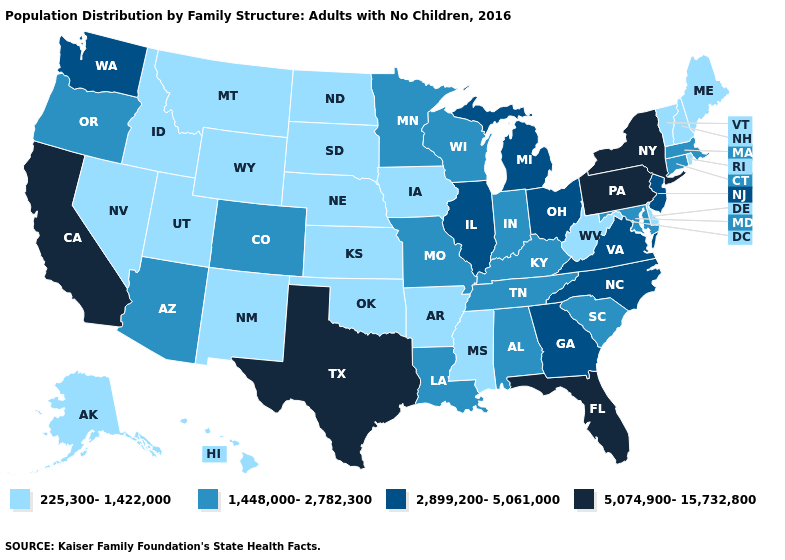Does the first symbol in the legend represent the smallest category?
Answer briefly. Yes. What is the value of Delaware?
Give a very brief answer. 225,300-1,422,000. Which states hav the highest value in the MidWest?
Keep it brief. Illinois, Michigan, Ohio. What is the lowest value in the South?
Quick response, please. 225,300-1,422,000. What is the value of Tennessee?
Keep it brief. 1,448,000-2,782,300. Does New Hampshire have the lowest value in the Northeast?
Write a very short answer. Yes. Does New Jersey have a higher value than Pennsylvania?
Be succinct. No. Which states have the lowest value in the MidWest?
Keep it brief. Iowa, Kansas, Nebraska, North Dakota, South Dakota. Which states have the highest value in the USA?
Write a very short answer. California, Florida, New York, Pennsylvania, Texas. What is the value of Ohio?
Quick response, please. 2,899,200-5,061,000. What is the value of North Dakota?
Write a very short answer. 225,300-1,422,000. What is the value of Rhode Island?
Keep it brief. 225,300-1,422,000. Name the states that have a value in the range 2,899,200-5,061,000?
Give a very brief answer. Georgia, Illinois, Michigan, New Jersey, North Carolina, Ohio, Virginia, Washington. Which states hav the highest value in the Northeast?
Give a very brief answer. New York, Pennsylvania. Among the states that border Massachusetts , does New York have the highest value?
Concise answer only. Yes. 